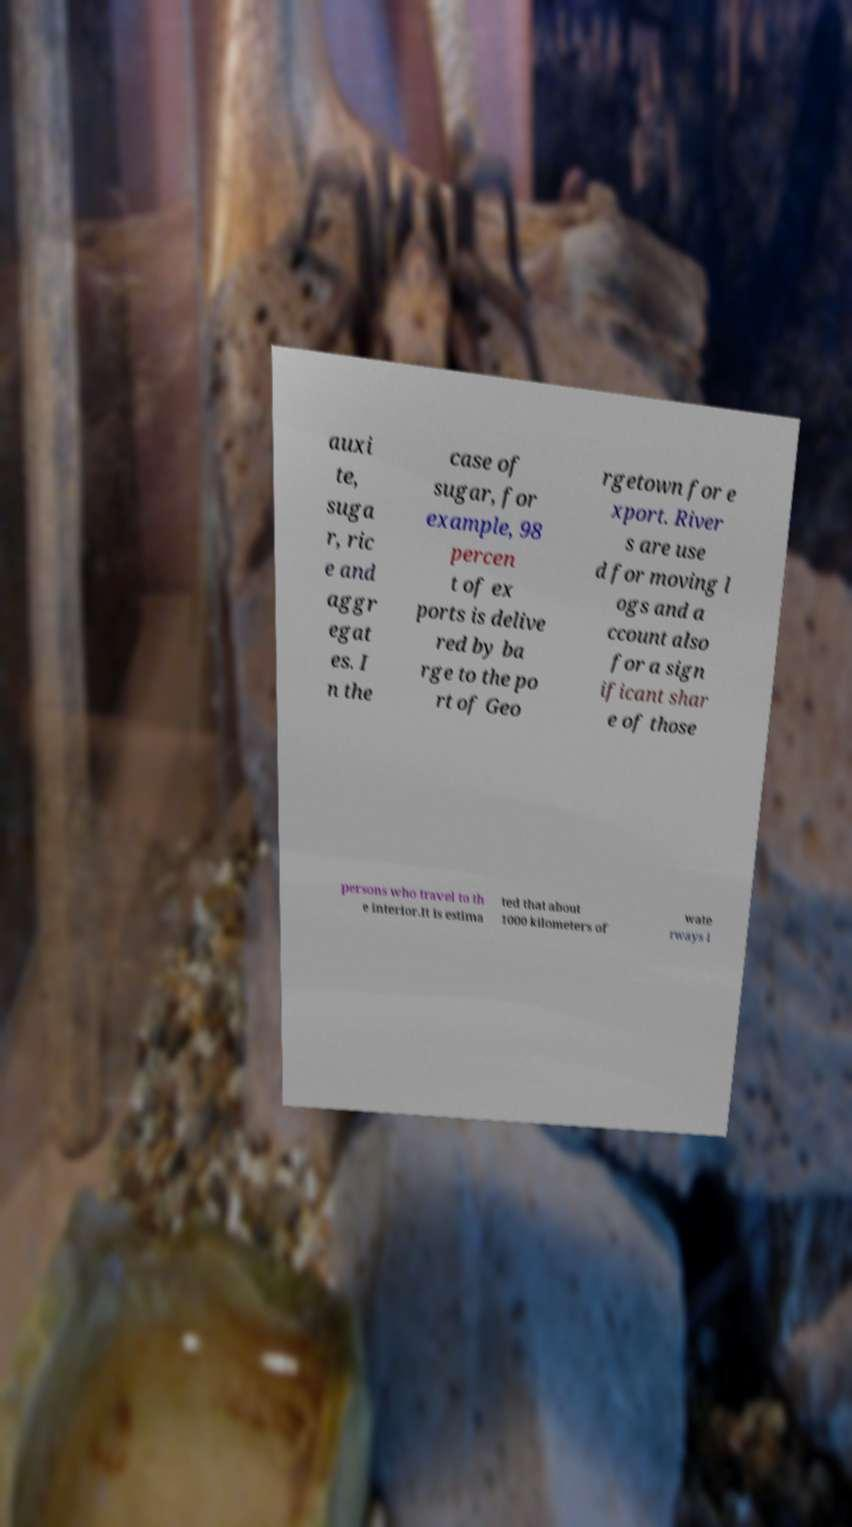There's text embedded in this image that I need extracted. Can you transcribe it verbatim? auxi te, suga r, ric e and aggr egat es. I n the case of sugar, for example, 98 percen t of ex ports is delive red by ba rge to the po rt of Geo rgetown for e xport. River s are use d for moving l ogs and a ccount also for a sign ificant shar e of those persons who travel to th e interior.It is estima ted that about 1000 kilometers of wate rways i 